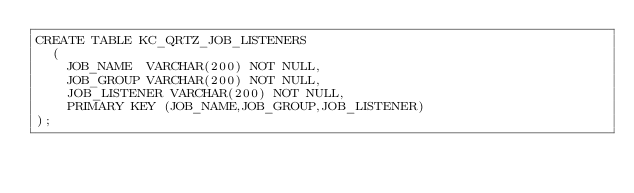<code> <loc_0><loc_0><loc_500><loc_500><_SQL_>CREATE TABLE KC_QRTZ_JOB_LISTENERS
  (
    JOB_NAME  VARCHAR(200) NOT NULL,
    JOB_GROUP VARCHAR(200) NOT NULL,
    JOB_LISTENER VARCHAR(200) NOT NULL,
    PRIMARY KEY (JOB_NAME,JOB_GROUP,JOB_LISTENER)
);</code> 